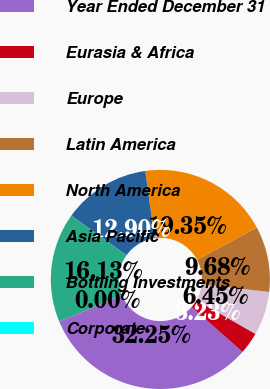Convert chart to OTSL. <chart><loc_0><loc_0><loc_500><loc_500><pie_chart><fcel>Year Ended December 31<fcel>Eurasia & Africa<fcel>Europe<fcel>Latin America<fcel>North America<fcel>Asia Pacific<fcel>Bottling Investments<fcel>Corporate<nl><fcel>32.25%<fcel>3.23%<fcel>6.45%<fcel>9.68%<fcel>19.35%<fcel>12.9%<fcel>16.13%<fcel>0.0%<nl></chart> 